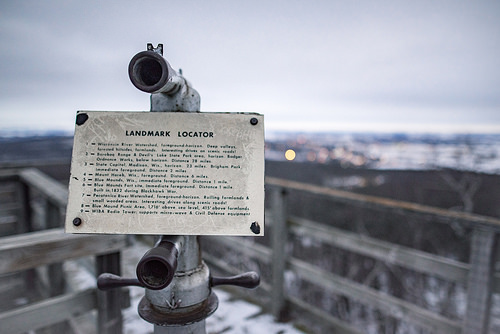<image>
Is there a note on the sky? No. The note is not positioned on the sky. They may be near each other, but the note is not supported by or resting on top of the sky. 